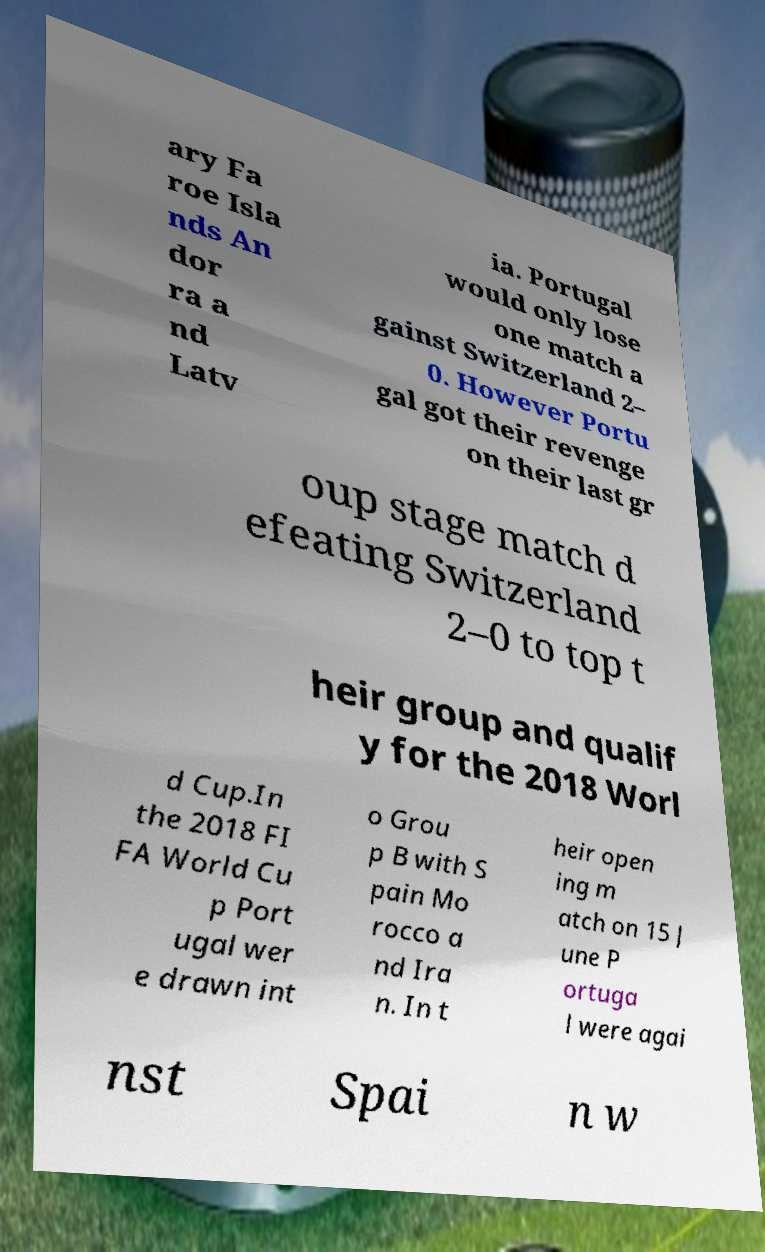Please identify and transcribe the text found in this image. ary Fa roe Isla nds An dor ra a nd Latv ia. Portugal would only lose one match a gainst Switzerland 2– 0. However Portu gal got their revenge on their last gr oup stage match d efeating Switzerland 2–0 to top t heir group and qualif y for the 2018 Worl d Cup.In the 2018 FI FA World Cu p Port ugal wer e drawn int o Grou p B with S pain Mo rocco a nd Ira n. In t heir open ing m atch on 15 J une P ortuga l were agai nst Spai n w 